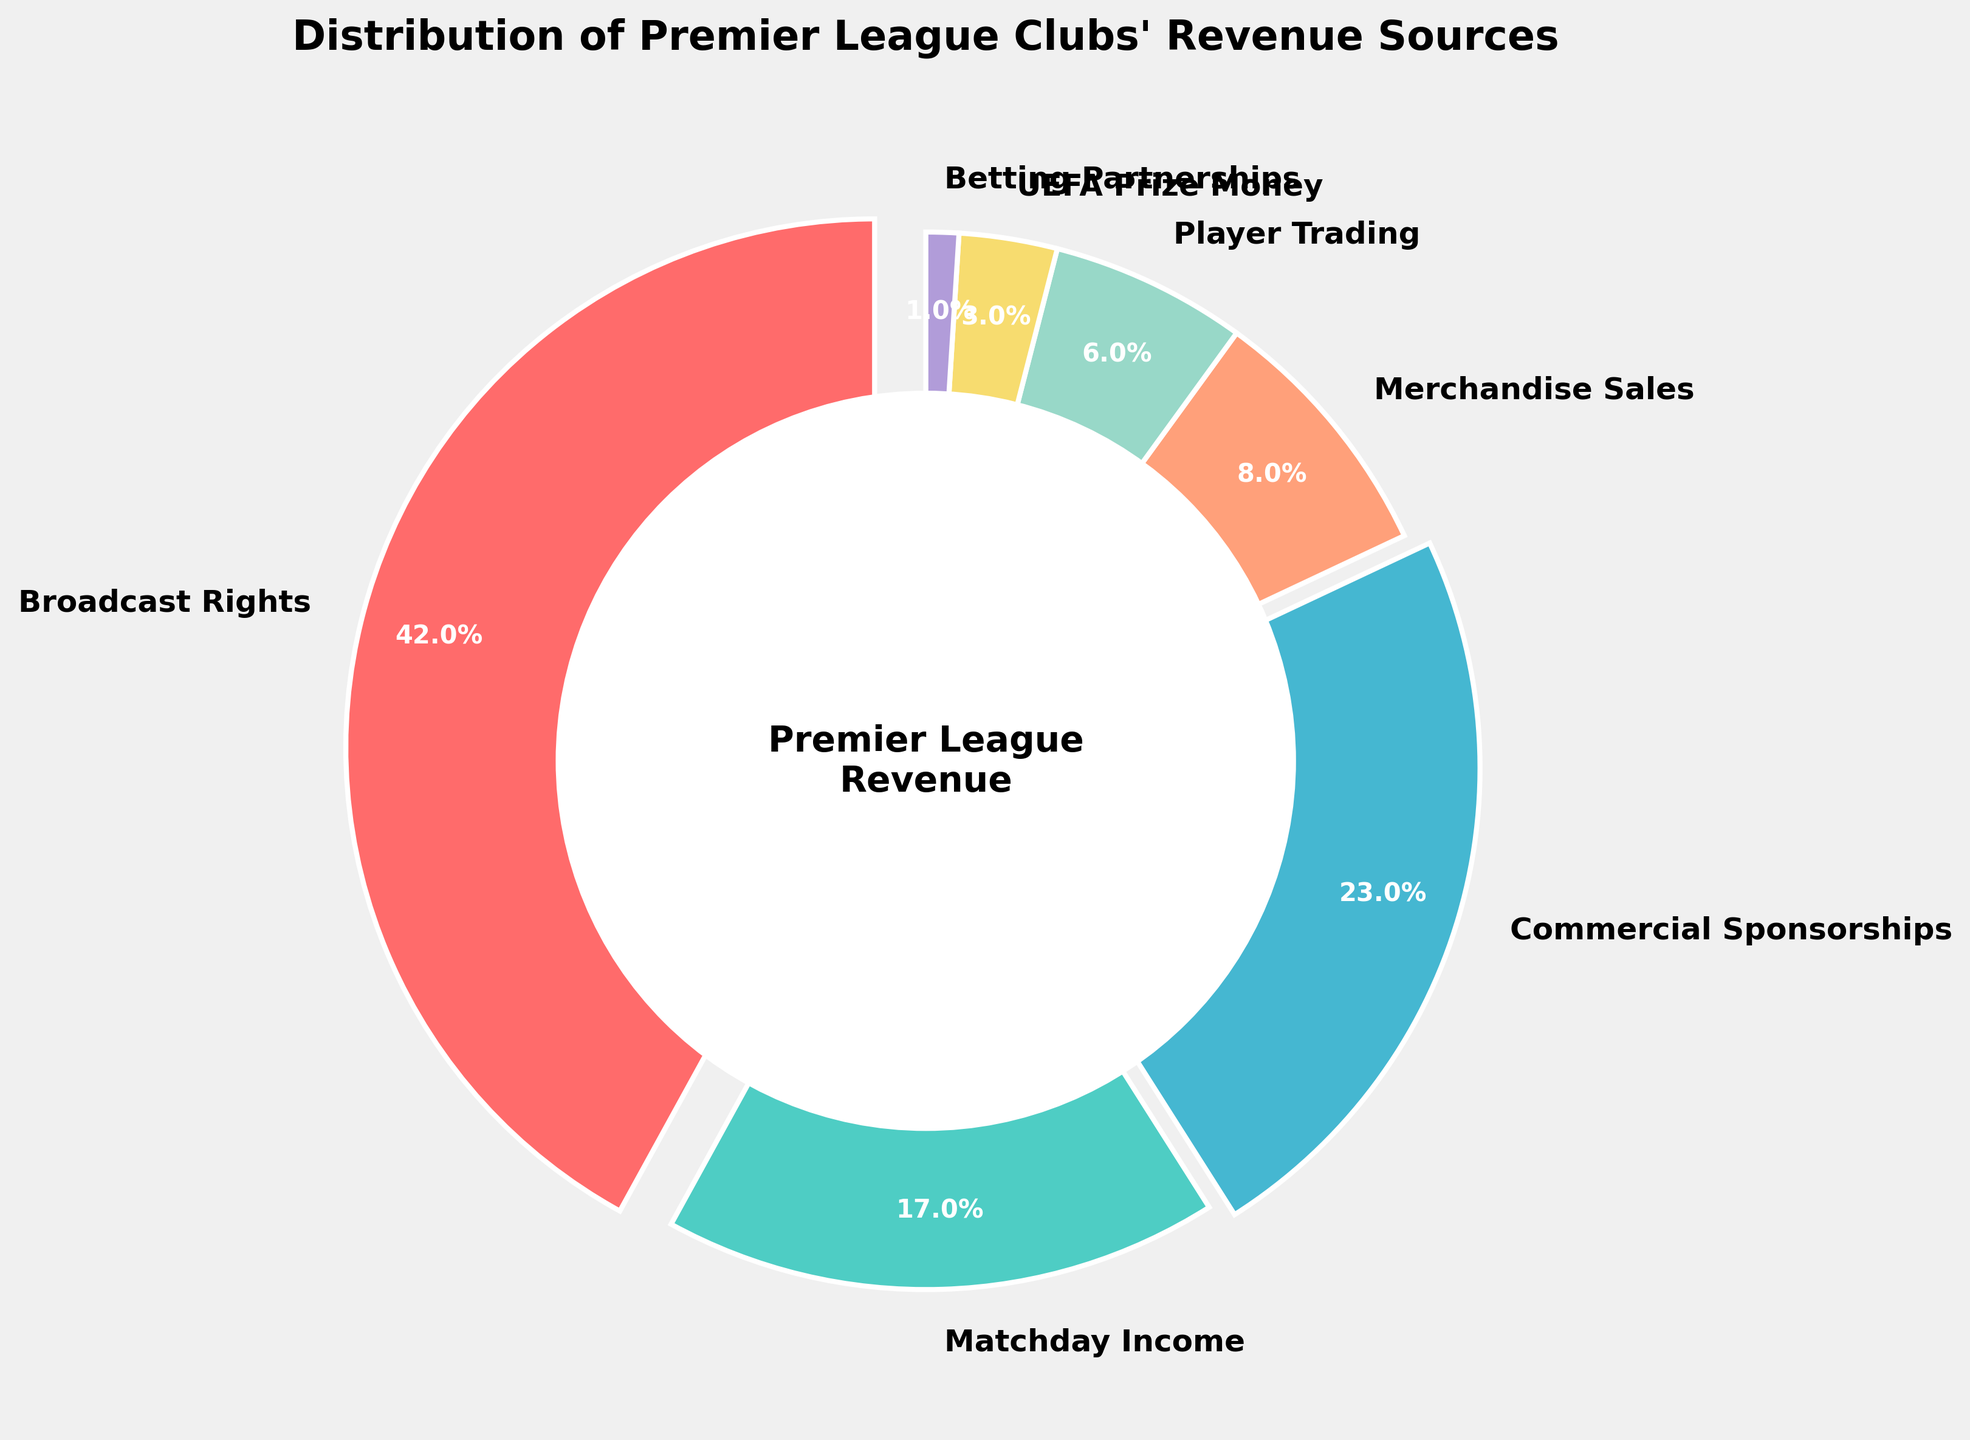What's the largest revenue source for Premier League clubs? The largest segment in the pie chart represents the biggest revenue source. The red segment labeled "Broadcast Rights" has the largest area.
Answer: Broadcast Rights How much more revenue do Premier League clubs get from Broadcast Rights compared to Matchday Income? Look at the percentages for Broadcast Rights (42%) and Matchday Income (17%). Subtract the smaller percentage from the larger one: 42% - 17% = 25%.
Answer: 25% What are the combined percentages of revenue from Merchandise Sales, Player Trading, and UEFA Prize Money? Add the percentages for Merchandise Sales (8%), Player Trading (6%), and UEFA Prize Money (3%): 8% + 6% + 3% = 17%.
Answer: 17% Which revenue source generates the least percentage of income for Premier League clubs? The smallest segment in the pie chart corresponds to the revenue source that generates the least income. The dark purple segment labeled "Betting Partnerships" is the smallest.
Answer: Betting Partnerships Is the revenue from Commercial Sponsorships greater than the revenue from Matchday Income? Compare the percentages for Commercial Sponsorships (23%) and Matchday Income (17%). Since 23% is greater than 17%, the revenue from Commercial Sponsorships is indeed greater.
Answer: Yes What's the total percentage of revenue generated by Broadcast Rights, Matchday Income, and Commercial Sponsorships? Add the percentages for Broadcast Rights (42%), Matchday Income (17%), and Commercial Sponsorships (23%): 42% + 17% + 23% = 82%.
Answer: 82% By how much does the percentage of revenue from Commercial Sponsorships exceed the combined percentage of Player Trading and UEFA Prize Money? First, find the total percentage for Player Trading (6%) and UEFA Prize Money (3%): 6% + 3% = 9%. Then subtract this from the Commercial Sponsorships percentage (23%): 23% - 9% = 14%.
Answer: 14% What color represents Matchday Income in the pie chart? Matchday Income is labeled in the pie chart with a light green segment.
Answer: Light green 